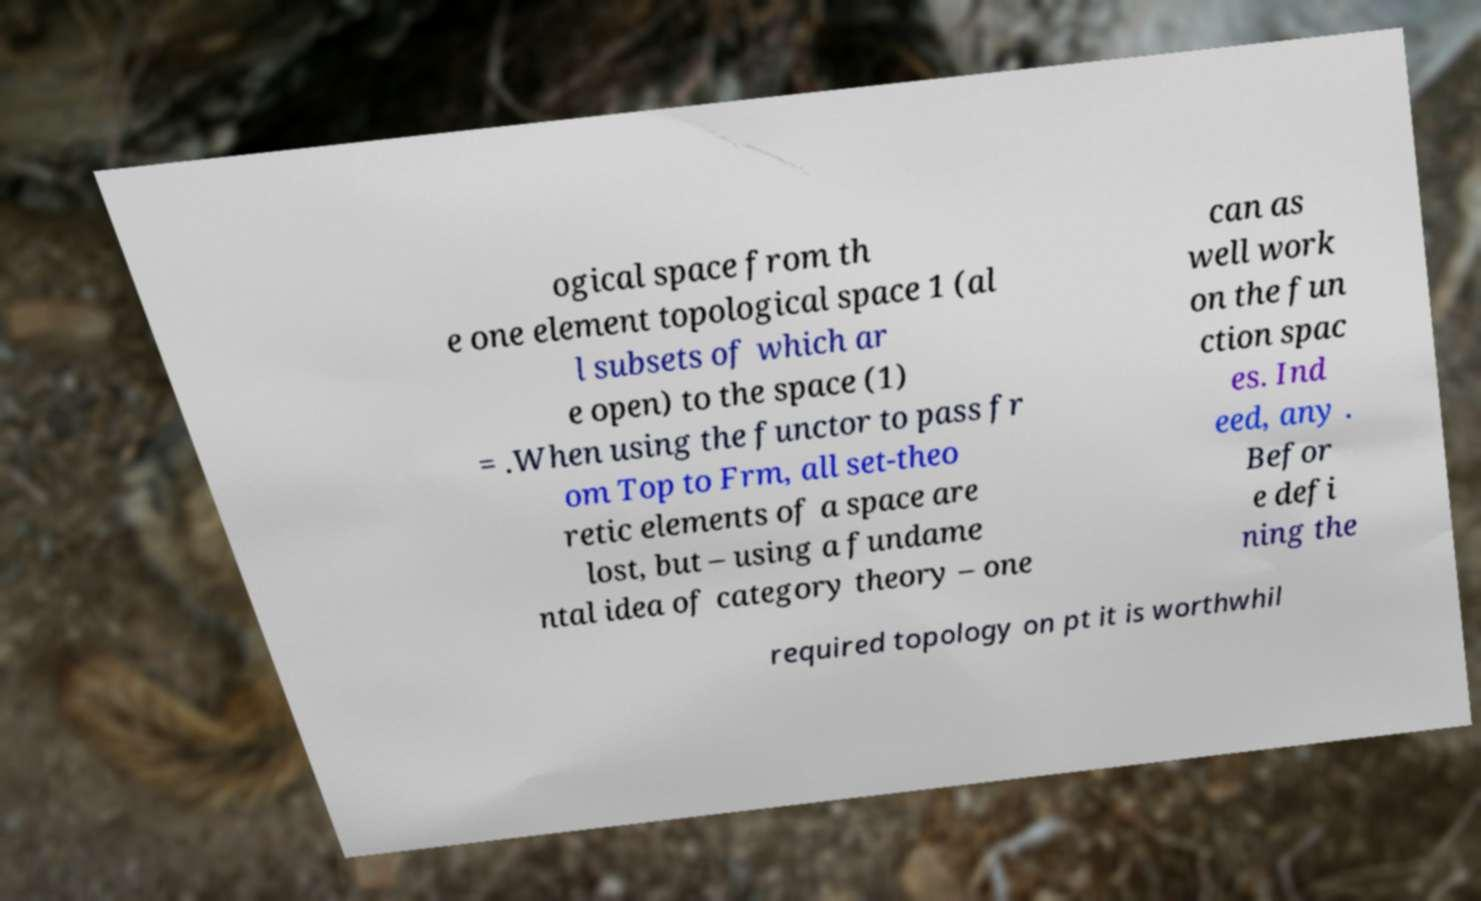Could you assist in decoding the text presented in this image and type it out clearly? ogical space from th e one element topological space 1 (al l subsets of which ar e open) to the space (1) = .When using the functor to pass fr om Top to Frm, all set-theo retic elements of a space are lost, but – using a fundame ntal idea of category theory – one can as well work on the fun ction spac es. Ind eed, any . Befor e defi ning the required topology on pt it is worthwhil 